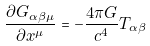<formula> <loc_0><loc_0><loc_500><loc_500>\frac { \partial G _ { \alpha \beta \mu } } { \partial x ^ { \mu } } = - \frac { 4 \pi G } { c ^ { 4 } } T _ { \alpha \beta }</formula> 